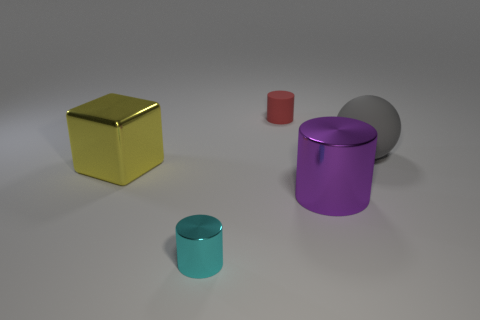Add 2 tiny cyan things. How many objects exist? 7 Subtract all cylinders. How many objects are left? 2 Subtract 0 gray cubes. How many objects are left? 5 Subtract all small cyan shiny cylinders. Subtract all large rubber spheres. How many objects are left? 3 Add 5 large matte objects. How many large matte objects are left? 6 Add 5 big purple metal objects. How many big purple metal objects exist? 6 